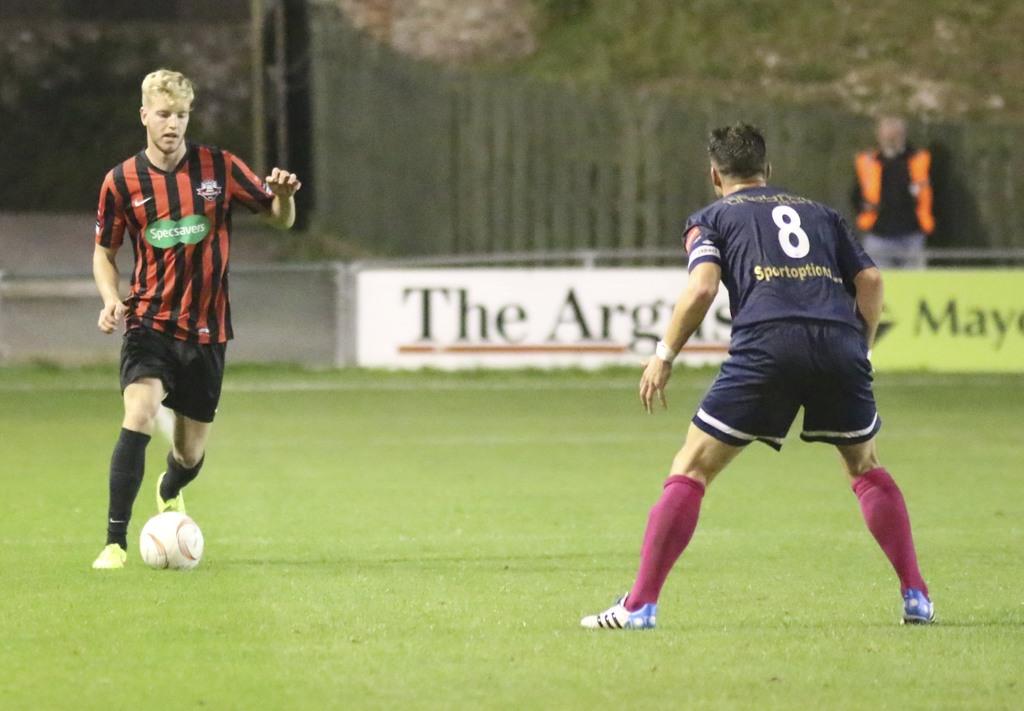What's the number on the back of the dark shirt?
Your answer should be compact. 8. What does it say on the chest of the player on the left?
Provide a succinct answer. Specsavers. 